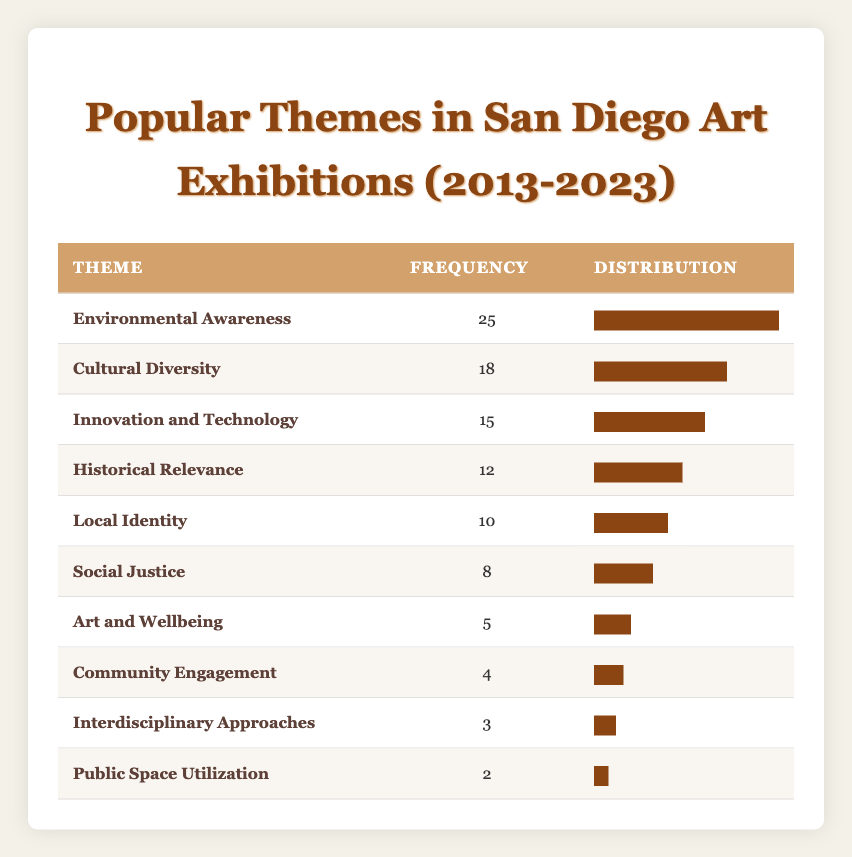What is the theme with the highest frequency? The table lists the themes along with their respective frequencies. By scanning through the frequencies, "Environmental Awareness" has the highest frequency of 25.
Answer: Environmental Awareness How many times was "Social Justice" represented in the exhibitions? The frequency for "Social Justice" is explicitly stated in the table as 8.
Answer: 8 Which two themes have the least representation in the exhibitions? The table shows that "Public Space Utilization" has the lowest frequency at 2, and "Interdisciplinary Approaches" follows with a frequency of 3.
Answer: Public Space Utilization and Interdisciplinary Approaches What is the combined frequency of "Local Identity," "Social Justice," and "Art and Wellbeing"? To find the combined frequency, we add the individual frequencies: 10 (Local Identity) + 8 (Social Justice) + 5 (Art and Wellbeing) = 23.
Answer: 23 True or False: "Cultural Diversity" was more popular than "Innovation and Technology." By comparing the frequencies, "Cultural Diversity" has a frequency of 18, while "Innovation and Technology" has a frequency of 15. Therefore, the statement is true.
Answer: True What is the average frequency of the themes listed in the table? First, we sum all the frequencies: 25 + 18 + 15 + 12 + 10 + 8 + 5 + 4 + 3 + 2 =  92. There are 10 themes, so we divide the total frequency by the number of themes: 92 / 10 = 9.2.
Answer: 9.2 Is "Community Engagement" more common than "Art and Wellbeing"? The frequency for "Community Engagement" is 4, while "Art and Wellbeing" has a frequency of 5. Since 4 is less than 5, the statement is false.
Answer: False Which theme has the highest frequency difference from "Public Space Utilization"? The frequency for "Public Space Utilization" is 2. The theme with the highest frequency is "Environmental Awareness" at 25. The difference is calculated as 25 - 2 = 23.
Answer: Environmental Awareness What percentage of the total themes does "Historical Relevance" represent? The frequency of "Historical Relevance" is 12. We first calculate the total frequency, which is 92. Then the percentage is calculated as (12 / 92) * 100 = 13.04%.
Answer: 13.04% 